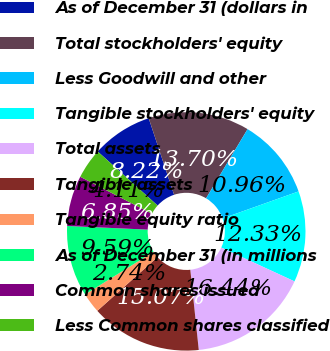Convert chart to OTSL. <chart><loc_0><loc_0><loc_500><loc_500><pie_chart><fcel>As of December 31 (dollars in<fcel>Total stockholders' equity<fcel>Less Goodwill and other<fcel>Tangible stockholders' equity<fcel>Total assets<fcel>Tangible assets<fcel>Tangible equity ratio<fcel>As of December 31 (in millions<fcel>Common shares issued<fcel>Less Common shares classified<nl><fcel>8.22%<fcel>13.7%<fcel>10.96%<fcel>12.33%<fcel>16.44%<fcel>15.07%<fcel>2.74%<fcel>9.59%<fcel>6.85%<fcel>4.11%<nl></chart> 